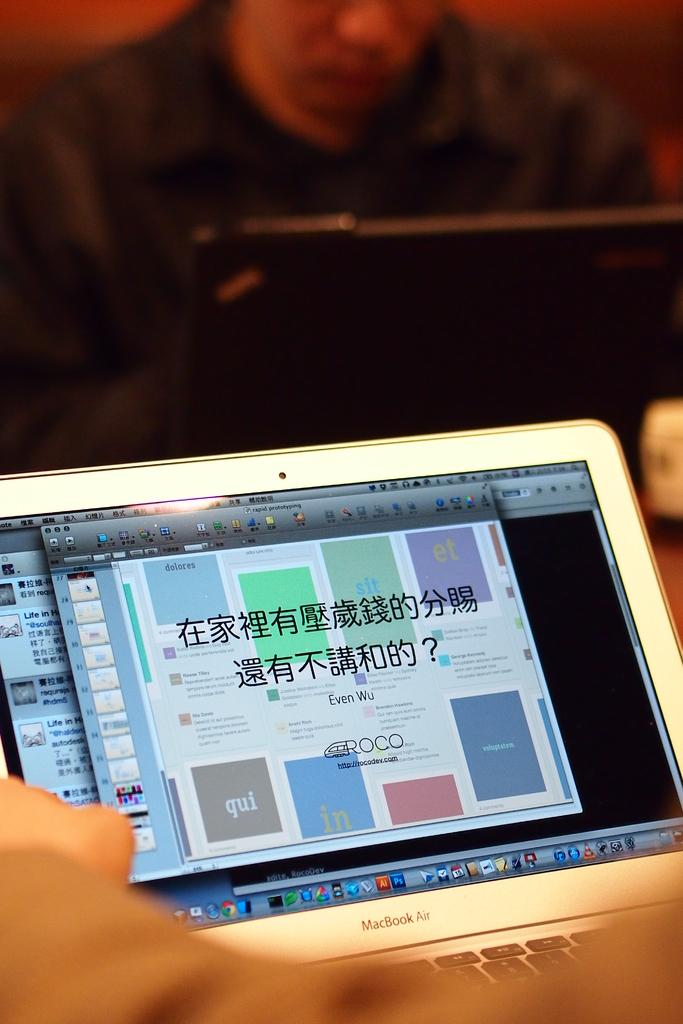What is the main object in the image? There is a laptop screen in the image. What is located below the laptop screen? There is a keyboard with keys in the image. What part of a person can be seen in the image? A human hand is visible at the bottom of the image. Can you describe the background of the image? There is a person and a laptop present in the background of the image. What type of bird can be seen polishing its wing in the image? There is no bird present in the image, and therefore no such activity can be observed. 